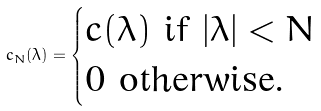Convert formula to latex. <formula><loc_0><loc_0><loc_500><loc_500>c _ { N } ( \lambda ) = \begin{cases} c ( \lambda ) \text { if } | \lambda | < N \\ 0 \text { otherwise.} \end{cases}</formula> 